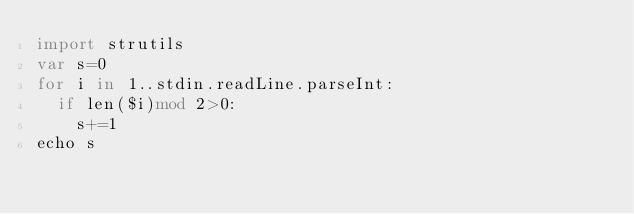Convert code to text. <code><loc_0><loc_0><loc_500><loc_500><_Nim_>import strutils
var s=0
for i in 1..stdin.readLine.parseInt:
  if len($i)mod 2>0:
    s+=1
echo s</code> 